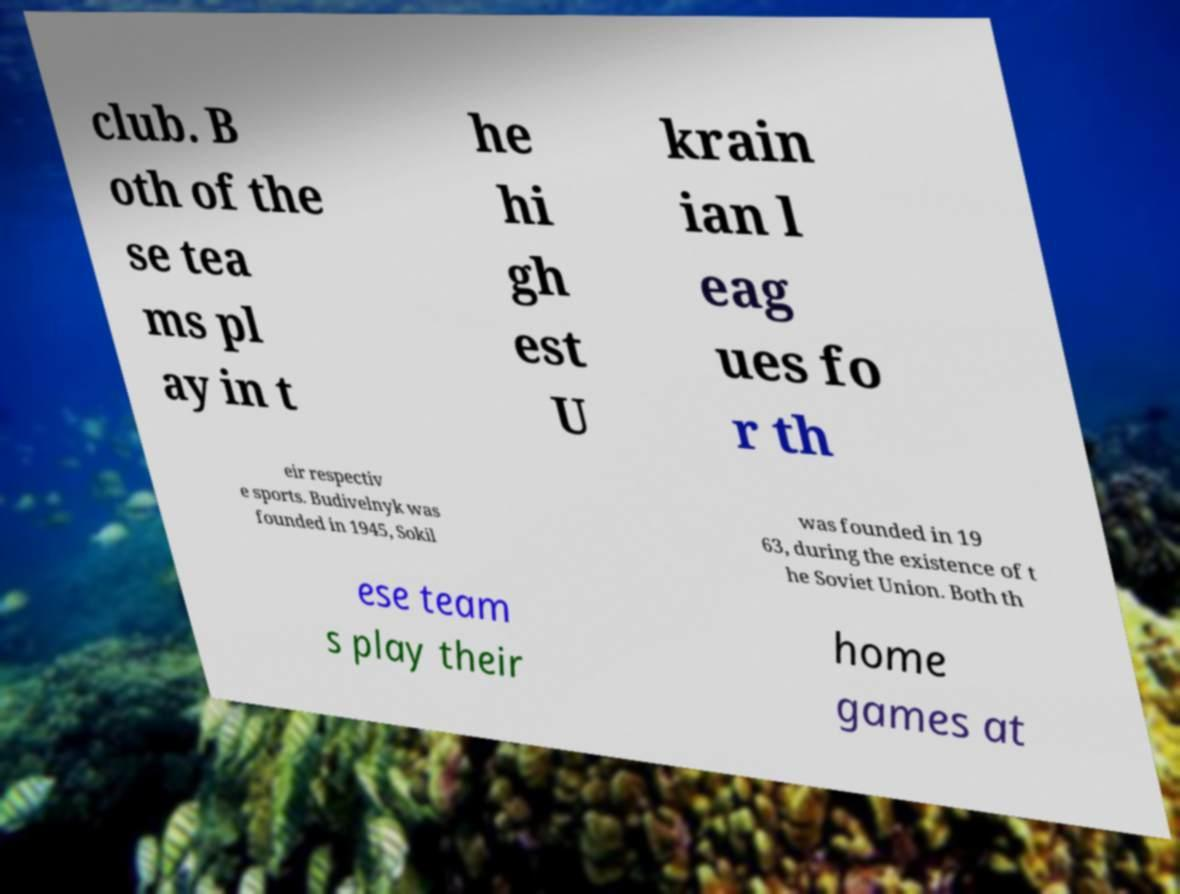Please read and relay the text visible in this image. What does it say? club. B oth of the se tea ms pl ay in t he hi gh est U krain ian l eag ues fo r th eir respectiv e sports. Budivelnyk was founded in 1945, Sokil was founded in 19 63, during the existence of t he Soviet Union. Both th ese team s play their home games at 